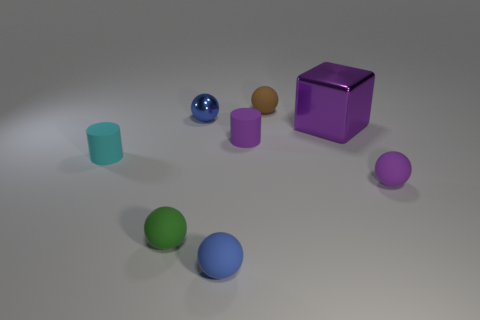Subtract all purple rubber balls. How many balls are left? 4 Subtract all yellow cylinders. How many blue spheres are left? 2 Add 2 tiny yellow objects. How many objects exist? 10 Subtract all purple spheres. How many spheres are left? 4 Subtract all balls. How many objects are left? 3 Subtract 3 balls. How many balls are left? 2 Subtract all yellow cubes. Subtract all yellow cylinders. How many cubes are left? 1 Subtract all tiny brown rubber things. Subtract all rubber objects. How many objects are left? 1 Add 6 metallic balls. How many metallic balls are left? 7 Add 1 small yellow objects. How many small yellow objects exist? 1 